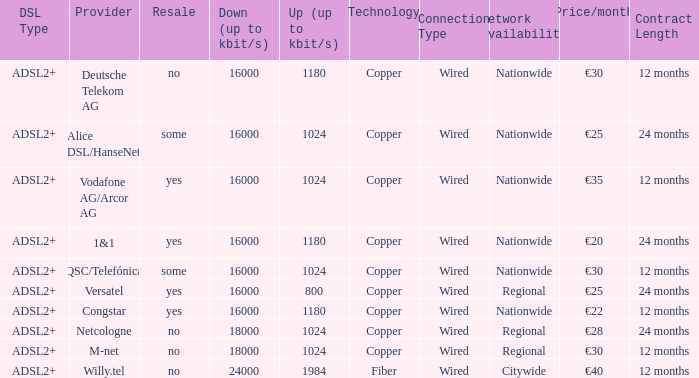What is download bandwith where the provider is deutsche telekom ag? 16000.0. 